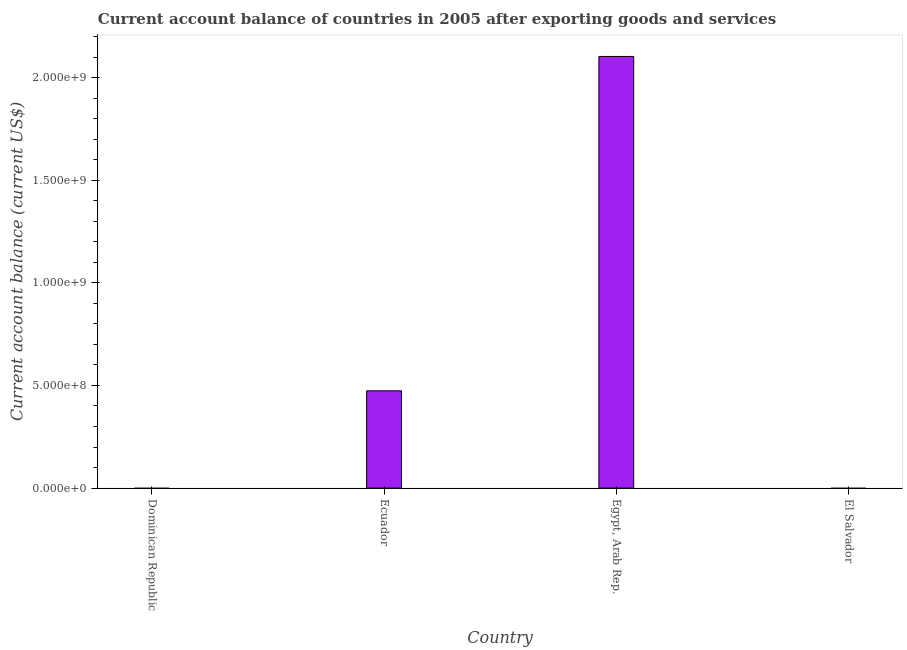Does the graph contain grids?
Your answer should be very brief. No. What is the title of the graph?
Your answer should be very brief. Current account balance of countries in 2005 after exporting goods and services. What is the label or title of the X-axis?
Make the answer very short. Country. What is the label or title of the Y-axis?
Ensure brevity in your answer.  Current account balance (current US$). What is the current account balance in Egypt, Arab Rep.?
Make the answer very short. 2.10e+09. Across all countries, what is the maximum current account balance?
Offer a terse response. 2.10e+09. In which country was the current account balance maximum?
Provide a short and direct response. Egypt, Arab Rep. What is the sum of the current account balance?
Keep it short and to the point. 2.58e+09. What is the difference between the current account balance in Ecuador and Egypt, Arab Rep.?
Provide a succinct answer. -1.63e+09. What is the average current account balance per country?
Offer a very short reply. 6.44e+08. What is the median current account balance?
Provide a short and direct response. 2.37e+08. In how many countries, is the current account balance greater than 100000000 US$?
Keep it short and to the point. 2. What is the ratio of the current account balance in Ecuador to that in Egypt, Arab Rep.?
Provide a succinct answer. 0.23. Is the difference between the current account balance in Ecuador and Egypt, Arab Rep. greater than the difference between any two countries?
Your answer should be very brief. No. Is the sum of the current account balance in Ecuador and Egypt, Arab Rep. greater than the maximum current account balance across all countries?
Your answer should be compact. Yes. What is the difference between the highest and the lowest current account balance?
Provide a succinct answer. 2.10e+09. What is the difference between two consecutive major ticks on the Y-axis?
Offer a very short reply. 5.00e+08. What is the Current account balance (current US$) of Ecuador?
Your answer should be very brief. 4.74e+08. What is the Current account balance (current US$) in Egypt, Arab Rep.?
Offer a terse response. 2.10e+09. What is the difference between the Current account balance (current US$) in Ecuador and Egypt, Arab Rep.?
Make the answer very short. -1.63e+09. What is the ratio of the Current account balance (current US$) in Ecuador to that in Egypt, Arab Rep.?
Give a very brief answer. 0.23. 